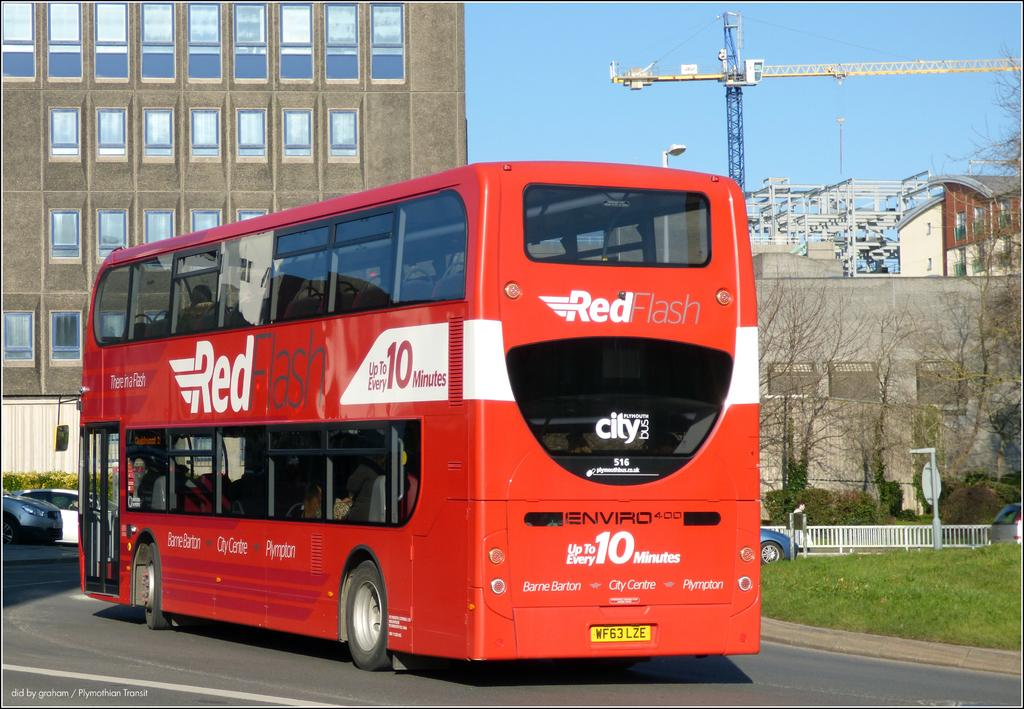Provide a one-sentence caption for the provided image. A Red Flash bus advertises that it arrives every 10 minutes. 